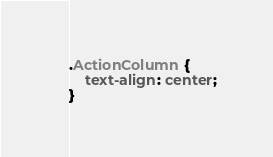Convert code to text. <code><loc_0><loc_0><loc_500><loc_500><_CSS_>.ActionColumn {
    text-align: center;
}
</code> 